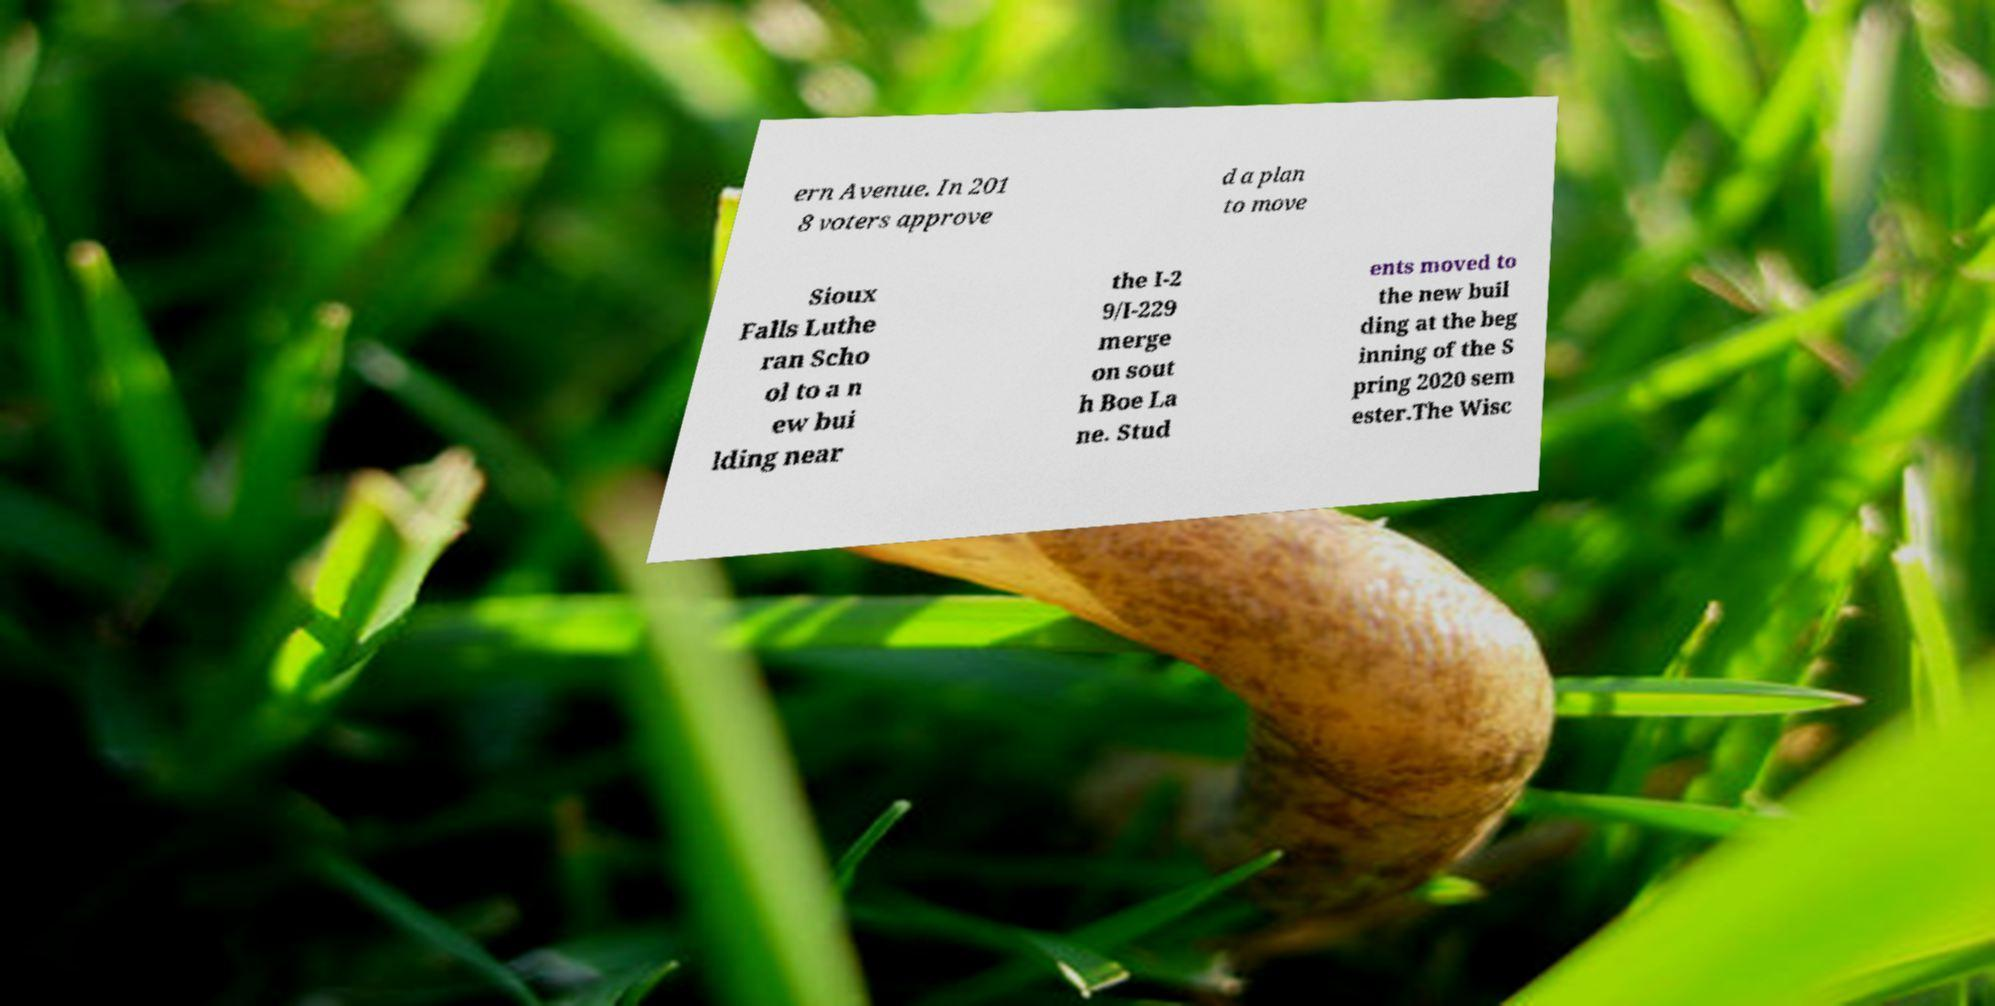Can you read and provide the text displayed in the image?This photo seems to have some interesting text. Can you extract and type it out for me? ern Avenue. In 201 8 voters approve d a plan to move Sioux Falls Luthe ran Scho ol to a n ew bui lding near the I-2 9/I-229 merge on sout h Boe La ne. Stud ents moved to the new buil ding at the beg inning of the S pring 2020 sem ester.The Wisc 